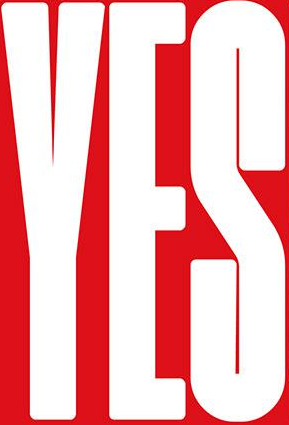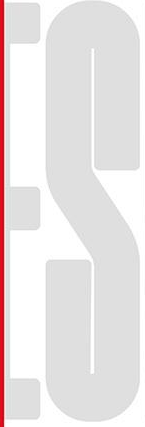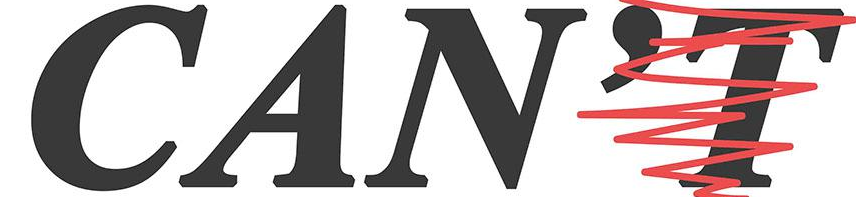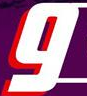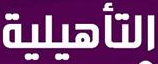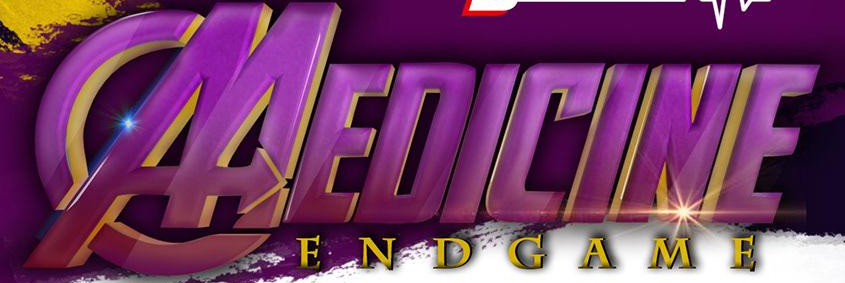Identify the words shown in these images in order, separated by a semicolon. YES; ES; CAN'T; g; ###; MEDICINE 